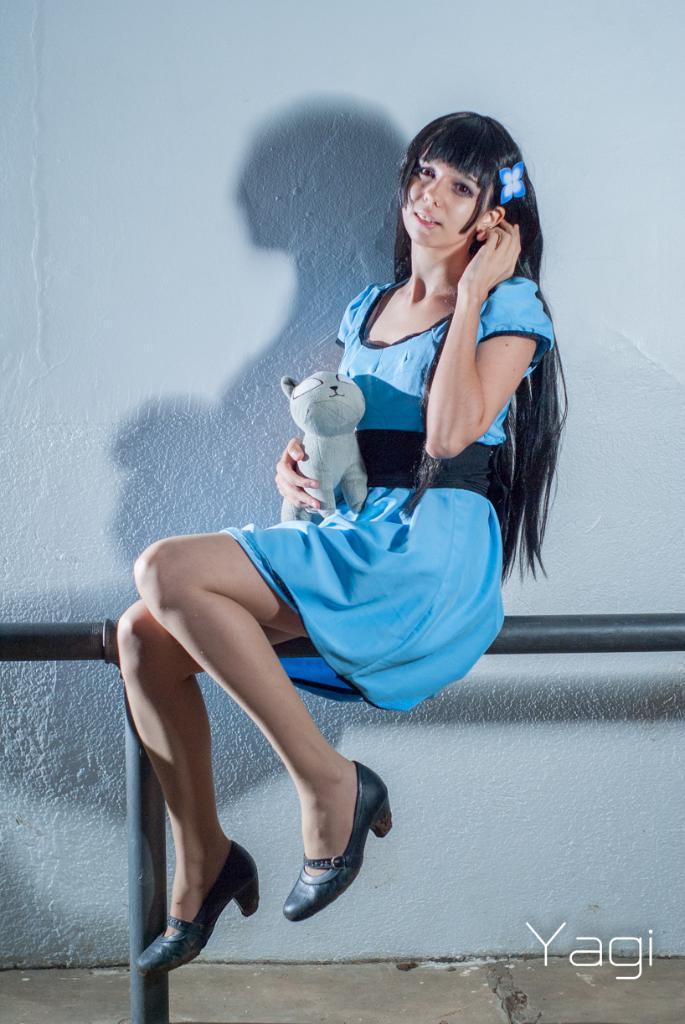Please provide a concise description of this image. In this image I can see a woman is sitting on a rod fence and a text. In the background I can see a wall. This image is taken during a day. 